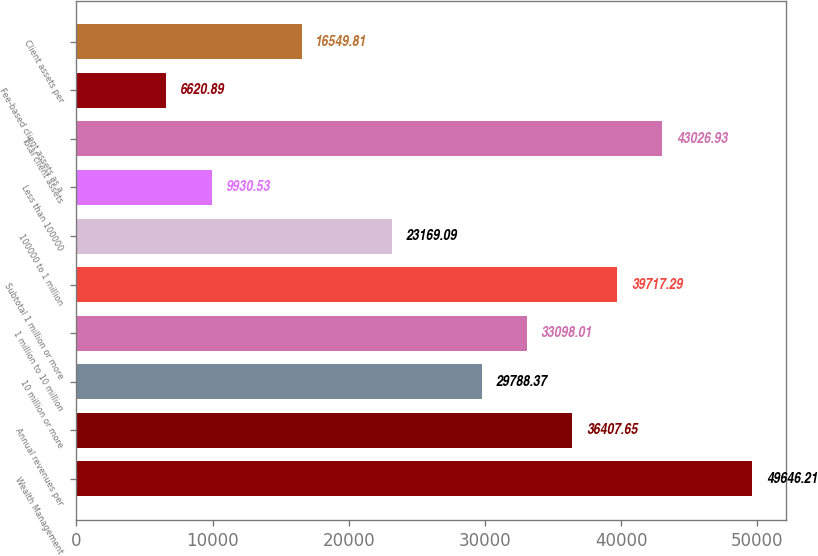<chart> <loc_0><loc_0><loc_500><loc_500><bar_chart><fcel>Wealth Management<fcel>Annual revenues per<fcel>10 million or more<fcel>1 million to 10 million<fcel>Subtotal 1 million or more<fcel>100000 to 1 million<fcel>Less than 100000<fcel>Total client assets<fcel>Fee-based client assets as a<fcel>Client assets per<nl><fcel>49646.2<fcel>36407.7<fcel>29788.4<fcel>33098<fcel>39717.3<fcel>23169.1<fcel>9930.53<fcel>43026.9<fcel>6620.89<fcel>16549.8<nl></chart> 